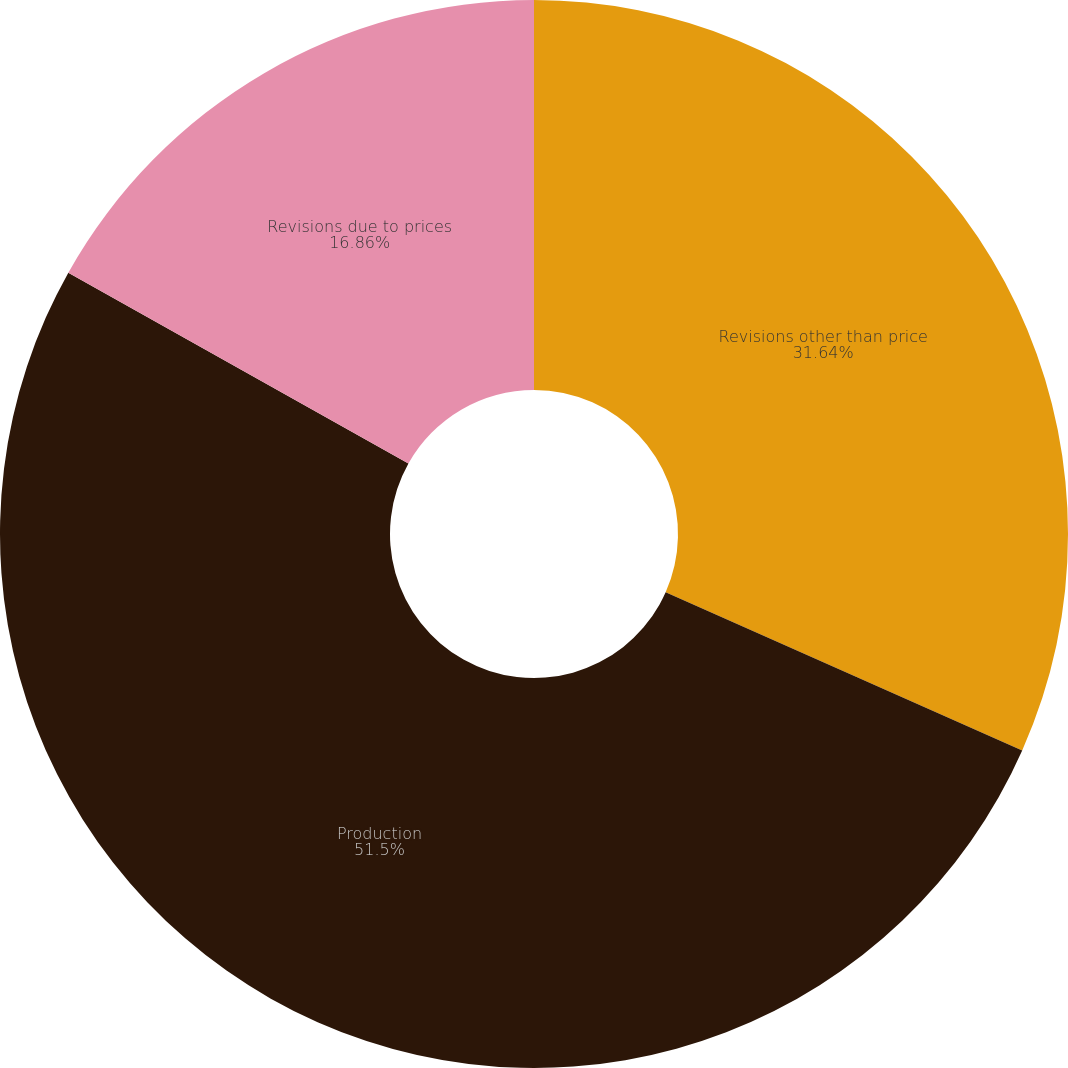Convert chart to OTSL. <chart><loc_0><loc_0><loc_500><loc_500><pie_chart><fcel>Revisions other than price<fcel>Production<fcel>Revisions due to prices<nl><fcel>31.64%<fcel>51.5%<fcel>16.86%<nl></chart> 